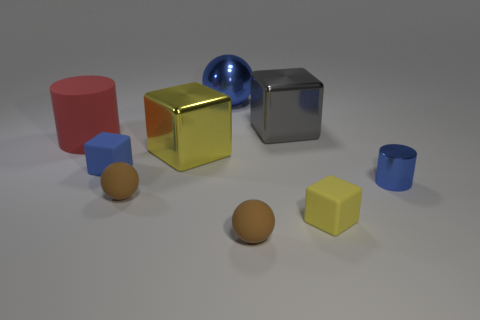Subtract all small brown rubber spheres. How many spheres are left? 1 Subtract all blue spheres. How many spheres are left? 2 Subtract all cylinders. How many objects are left? 7 Subtract all yellow spheres. Subtract all cyan cylinders. How many spheres are left? 3 Subtract all purple cylinders. How many purple balls are left? 0 Subtract all large yellow objects. Subtract all large red rubber cylinders. How many objects are left? 7 Add 6 big red matte objects. How many big red matte objects are left? 7 Add 3 small purple shiny spheres. How many small purple shiny spheres exist? 3 Subtract 0 purple cylinders. How many objects are left? 9 Subtract 2 balls. How many balls are left? 1 